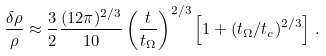Convert formula to latex. <formula><loc_0><loc_0><loc_500><loc_500>\frac { \delta \rho } { \rho } \approx \frac { 3 } { 2 } \frac { ( 1 2 \pi ) ^ { 2 / 3 } } { 1 0 } \left ( \frac { t } { t _ { \Omega } } \right ) ^ { 2 / 3 } \left [ 1 + ( t _ { \Omega } / t _ { c } ) ^ { 2 / 3 } \right ] \, .</formula> 